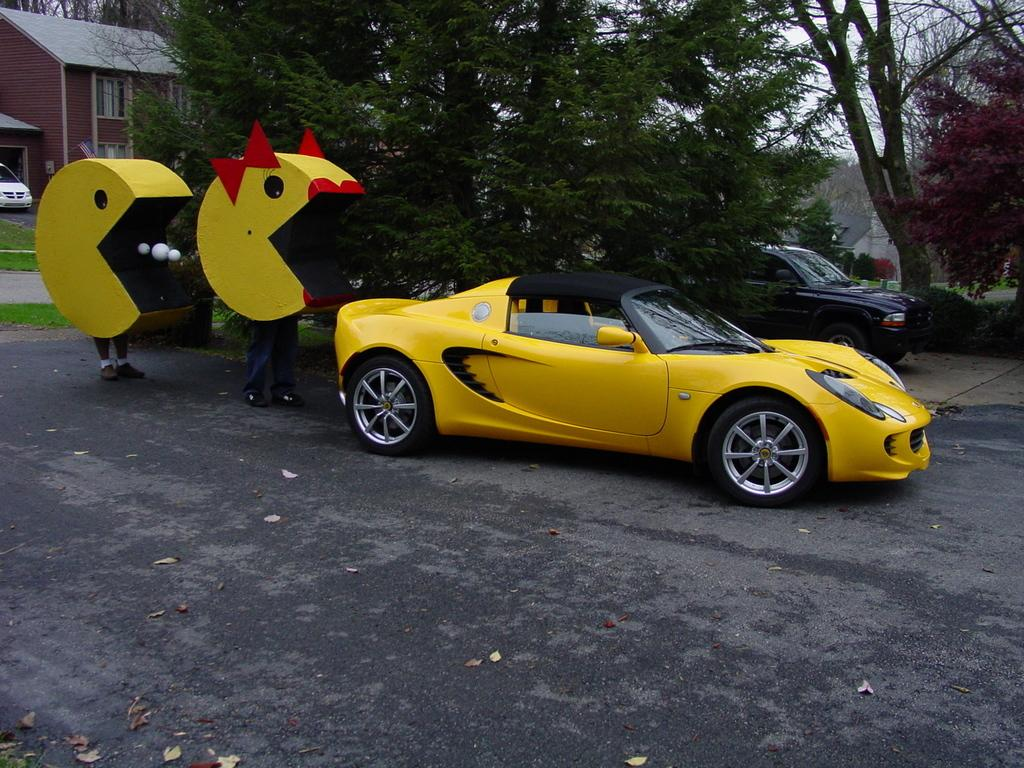What colors are the cars in the image? The cars in the image are in yellow, white, and black colors. What type of natural elements can be seen in the image? There are trees in the image. What type of man-made structures are present in the image? There are buildings in the image. What architectural feature is visible in the image? There are windows in the image. What are the two people holding in the image? One person is holding a yellow object, and the other is holding a red object. What is the color of the sky in the image? The sky is white in color. What type of trousers is the creator wearing in the image? There is no creator present in the image, and therefore no trousers can be observed. Is the camera visible in the image? There is no camera present in the image. 